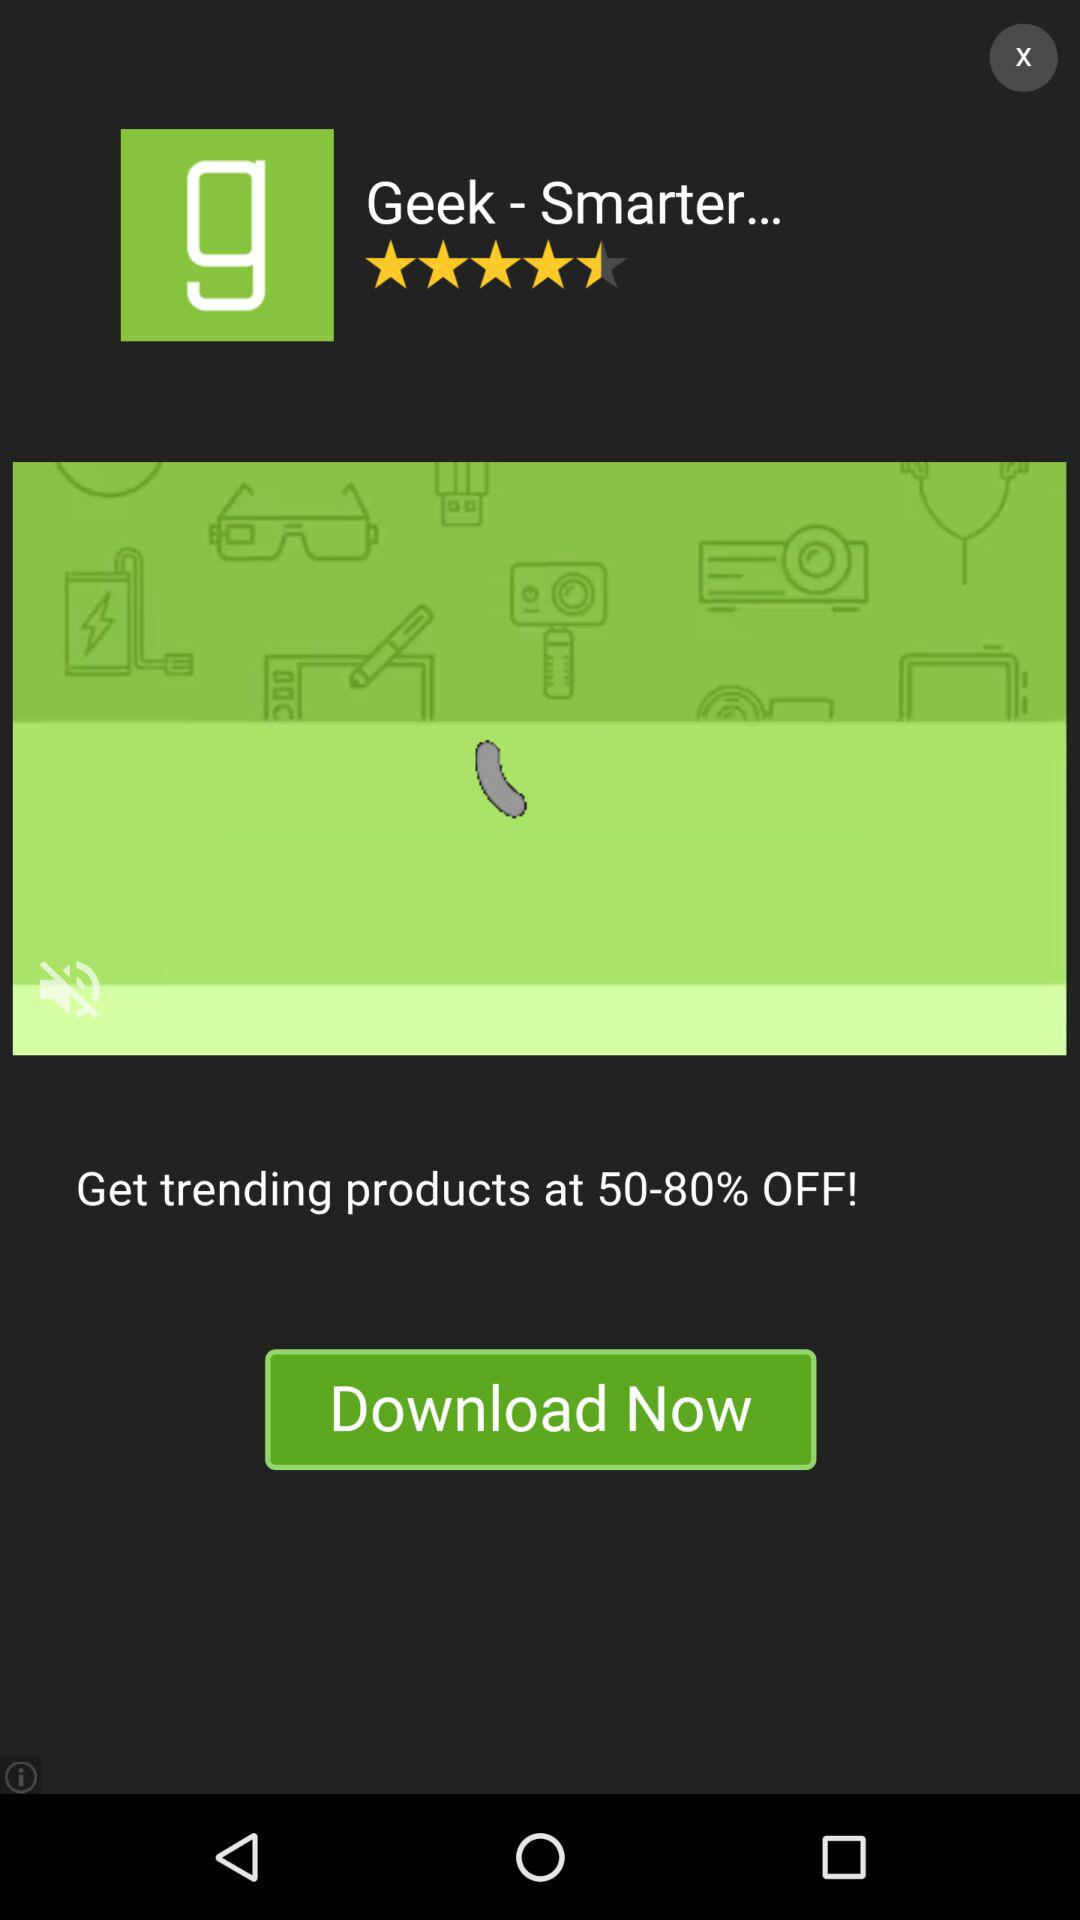What is the rating out of 5 for the application? The rating out of 5 for the application is 4.5 stars. 